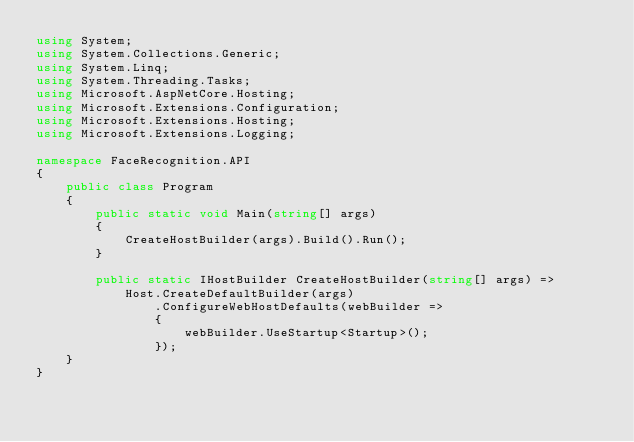<code> <loc_0><loc_0><loc_500><loc_500><_C#_>using System;
using System.Collections.Generic;
using System.Linq;
using System.Threading.Tasks;
using Microsoft.AspNetCore.Hosting;
using Microsoft.Extensions.Configuration;
using Microsoft.Extensions.Hosting;
using Microsoft.Extensions.Logging;

namespace FaceRecognition.API
{
    public class Program
    {
        public static void Main(string[] args)
        {
            CreateHostBuilder(args).Build().Run();
        }

        public static IHostBuilder CreateHostBuilder(string[] args) =>
            Host.CreateDefaultBuilder(args)
                .ConfigureWebHostDefaults(webBuilder =>
                {
                    webBuilder.UseStartup<Startup>();
                });
    }
}
</code> 